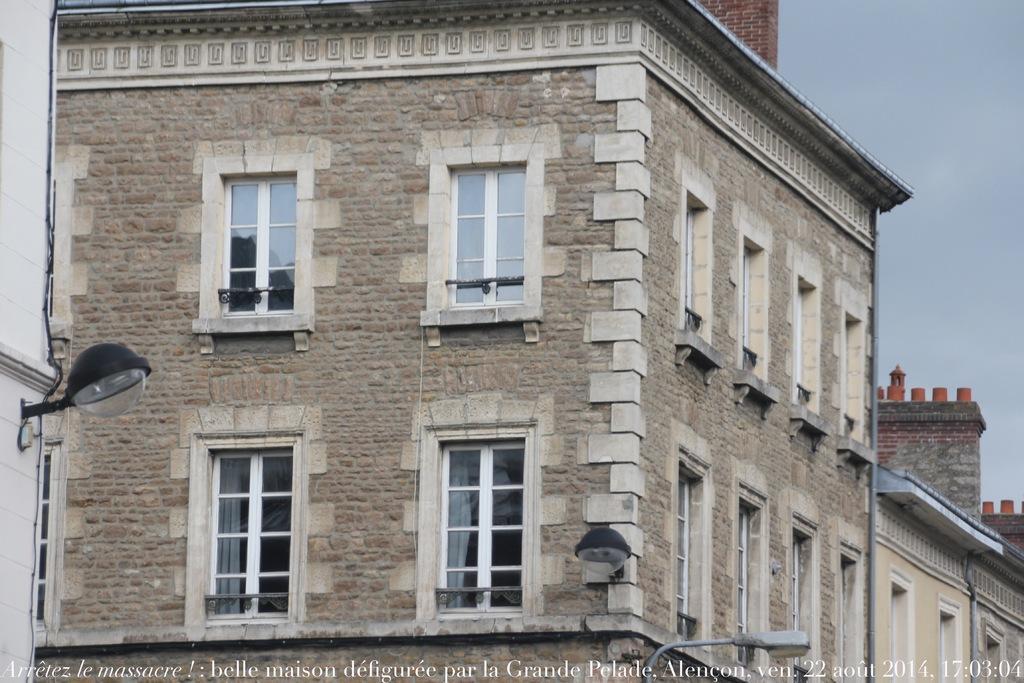Could you give a brief overview of what you see in this image? In this image, we can see buildings, walls, windows, lights, wires and pipes. At the bottom of the image, we can see the text. On the right side of the image, there is the sky. Here through the glass windows, we can see curtains. 